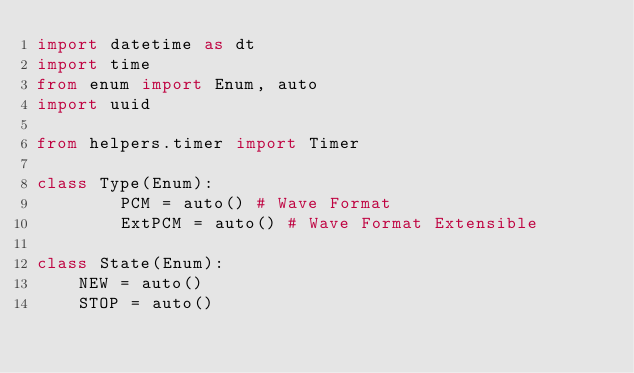<code> <loc_0><loc_0><loc_500><loc_500><_Python_>import datetime as dt
import time
from enum import Enum, auto
import uuid

from helpers.timer import Timer

class Type(Enum):
        PCM = auto() # Wave Format
        ExtPCM = auto() # Wave Format Extensible

class State(Enum):
    NEW = auto()
    STOP = auto()</code> 